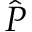<formula> <loc_0><loc_0><loc_500><loc_500>\hat { P }</formula> 